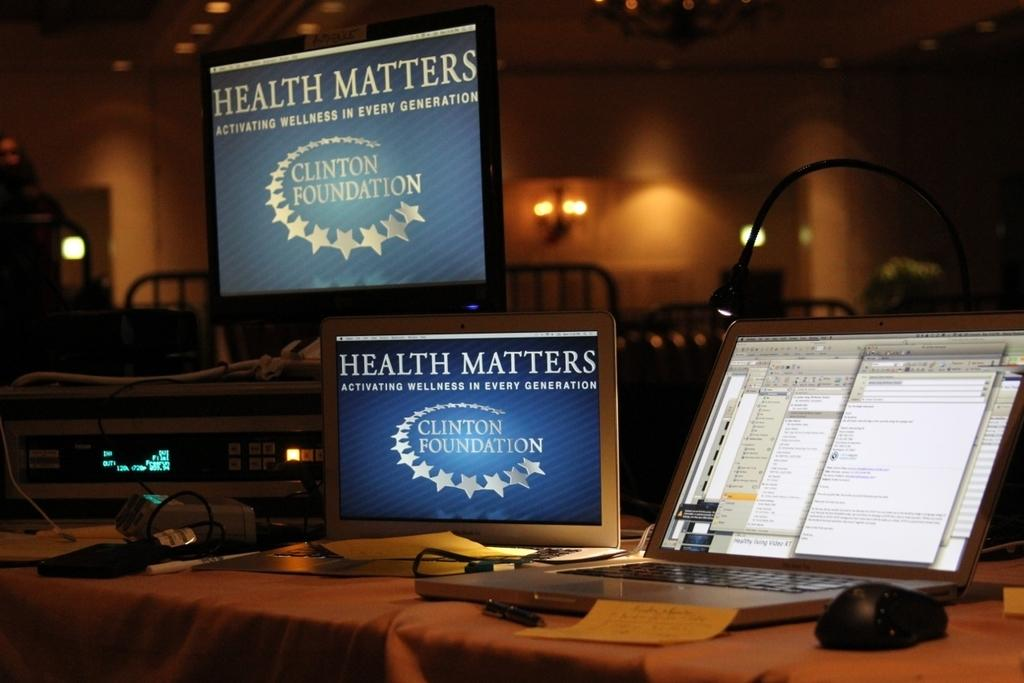<image>
Summarize the visual content of the image. Two blue screens with white words that say Health Matters. 